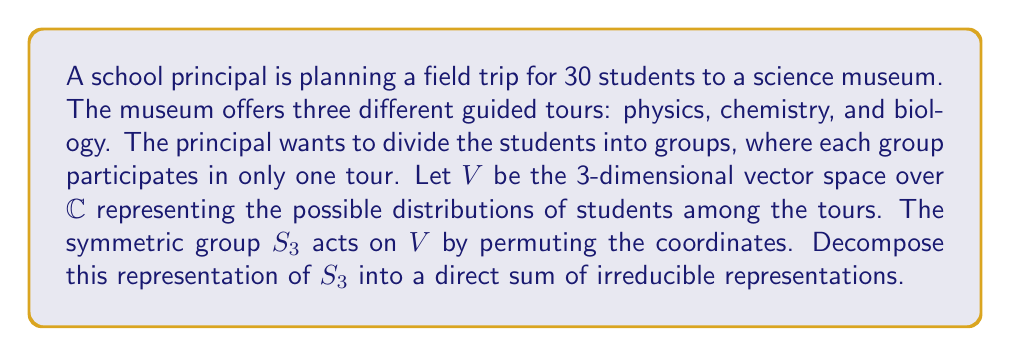Provide a solution to this math problem. Let's approach this step-by-step:

1) First, we need to identify the irreducible representations of $S_3$. $S_3$ has three irreducible representations:
   - The trivial representation, $\mathbf{1}$
   - The sign representation, $\varepsilon$
   - A 2-dimensional representation, $\mathbf{2}$

2) Now, let's consider the character of our representation $V$. For each element of $S_3$, we need to calculate its trace in the matrix representation:
   - Identity $(1)$: $\chi_V(1) = 3$
   - Transpositions $(12)$, $(23)$, $(13)$: $\chi_V((12)) = 1$
   - 3-cycles $(123)$, $(132)$: $\chi_V((123)) = 0$

3) We can decompose $V$ using the formula:
   $$V \cong a\mathbf{1} \oplus b\varepsilon \oplus c\mathbf{2}$$
   where $a$, $b$, and $c$ are non-negative integers we need to determine.

4) We can find these coefficients using the inner product of characters:
   $$a = \langle \chi_V, \chi_{\mathbf{1}} \rangle = \frac{1}{6}(3 \cdot 1 + 3 \cdot 1 + 2 \cdot 1) = 1$$
   $$b = \langle \chi_V, \chi_{\varepsilon} \rangle = \frac{1}{6}(3 \cdot 1 + 3 \cdot (-1) + 2 \cdot 1) = 0$$
   $$c = \langle \chi_V, \chi_{\mathbf{2}} \rangle = \frac{1}{6}(3 \cdot 2 + 3 \cdot 0 + 2 \cdot (-1)) = \frac{1}{2}$$

5) Therefore, the decomposition is:
   $$V \cong \mathbf{1} \oplus \mathbf{2}$$

This means that the representation $V$ can be decomposed into the direct sum of the trivial representation and the 2-dimensional irreducible representation of $S_3$.
Answer: $V \cong \mathbf{1} \oplus \mathbf{2}$ 